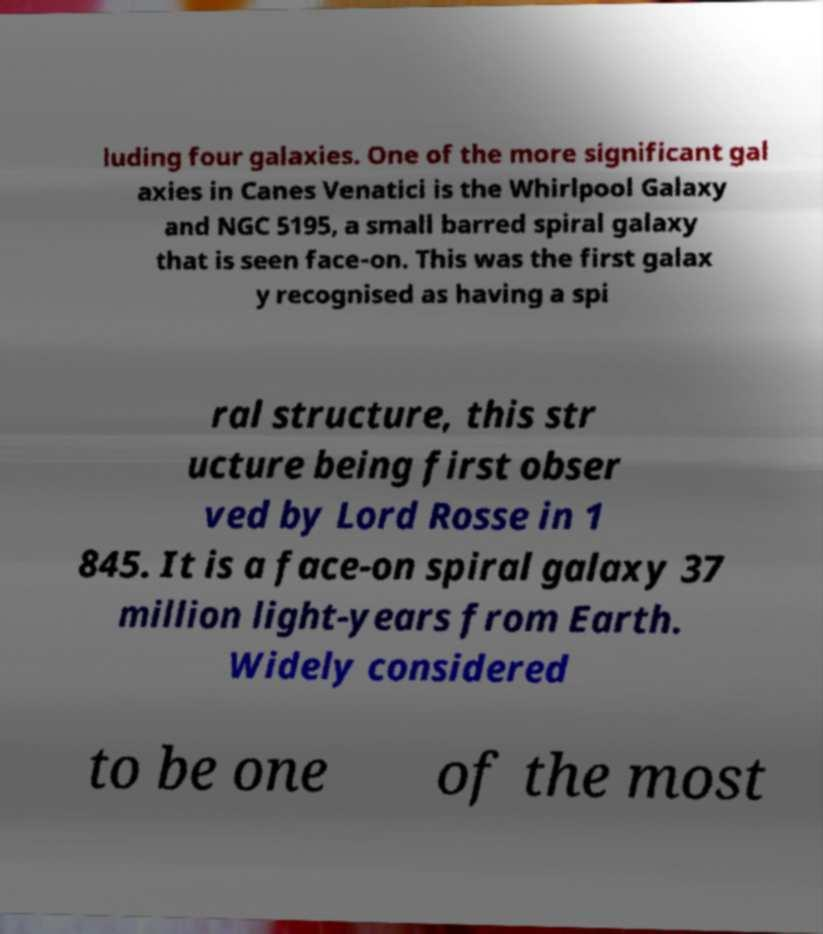Could you extract and type out the text from this image? luding four galaxies. One of the more significant gal axies in Canes Venatici is the Whirlpool Galaxy and NGC 5195, a small barred spiral galaxy that is seen face-on. This was the first galax y recognised as having a spi ral structure, this str ucture being first obser ved by Lord Rosse in 1 845. It is a face-on spiral galaxy 37 million light-years from Earth. Widely considered to be one of the most 